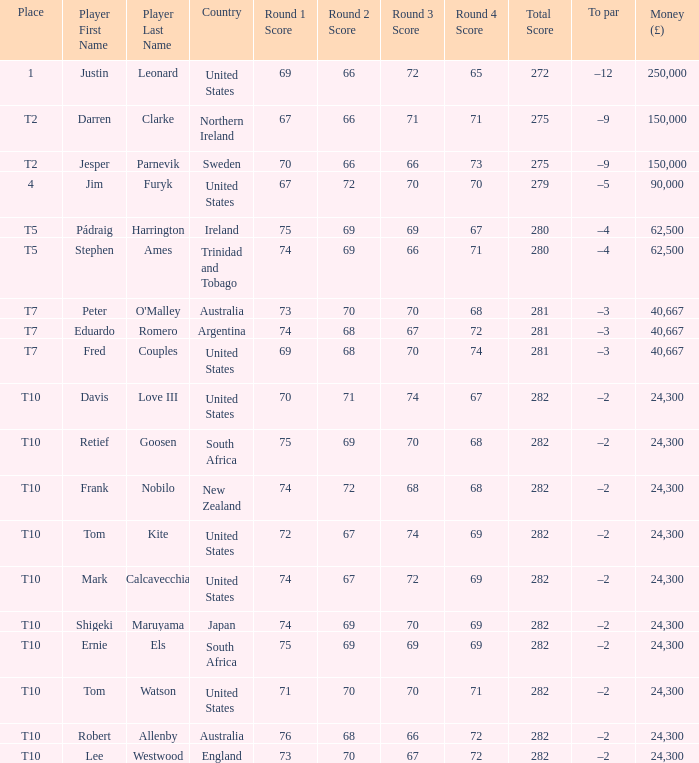Could you parse the entire table as a dict? {'header': ['Place', 'Player First Name', 'Player Last Name', 'Country', 'Round 1 Score', 'Round 2 Score', 'Round 3 Score', 'Round 4 Score', 'Total Score', 'To par', 'Money (£)'], 'rows': [['1', 'Justin', 'Leonard', 'United States', '69', '66', '72', '65', '272', '–12', '250,000'], ['T2', 'Darren', 'Clarke', 'Northern Ireland', '67', '66', '71', '71', '275', '–9', '150,000'], ['T2', 'Jesper', 'Parnevik', 'Sweden', '70', '66', '66', '73', '275', '–9', '150,000'], ['4', 'Jim', 'Furyk', 'United States', '67', '72', '70', '70', '279', '–5', '90,000'], ['T5', 'Pádraig', 'Harrington', 'Ireland', '75', '69', '69', '67', '280', '–4', '62,500'], ['T5', 'Stephen', 'Ames', 'Trinidad and Tobago', '74', '69', '66', '71', '280', '–4', '62,500'], ['T7', 'Peter', "O'Malley", 'Australia', '73', '70', '70', '68', '281', '–3', '40,667'], ['T7', 'Eduardo', 'Romero', 'Argentina', '74', '68', '67', '72', '281', '–3', '40,667'], ['T7', 'Fred', 'Couples', 'United States', '69', '68', '70', '74', '281', '–3', '40,667'], ['T10', 'Davis', 'Love III', 'United States', '70', '71', '74', '67', '282', '–2', '24,300'], ['T10', 'Retief', 'Goosen', 'South Africa', '75', '69', '70', '68', '282', '–2', '24,300'], ['T10', 'Frank', 'Nobilo', 'New Zealand', '74', '72', '68', '68', '282', '–2', '24,300'], ['T10', 'Tom', 'Kite', 'United States', '72', '67', '74', '69', '282', '–2', '24,300'], ['T10', 'Mark', 'Calcavecchia', 'United States', '74', '67', '72', '69', '282', '–2', '24,300'], ['T10', 'Shigeki', 'Maruyama', 'Japan', '74', '69', '70', '69', '282', '–2', '24,300'], ['T10', 'Ernie', 'Els', 'South Africa', '75', '69', '69', '69', '282', '–2', '24,300'], ['T10', 'Tom', 'Watson', 'United States', '71', '70', '70', '71', '282', '–2', '24,300'], ['T10', 'Robert', 'Allenby', 'Australia', '76', '68', '66', '72', '282', '–2', '24,300'], ['T10', 'Lee', 'Westwood', 'England', '73', '70', '67', '72', '282', '–2', '24,300']]} What is Lee Westwood's score? 73-70-67-72=282. 